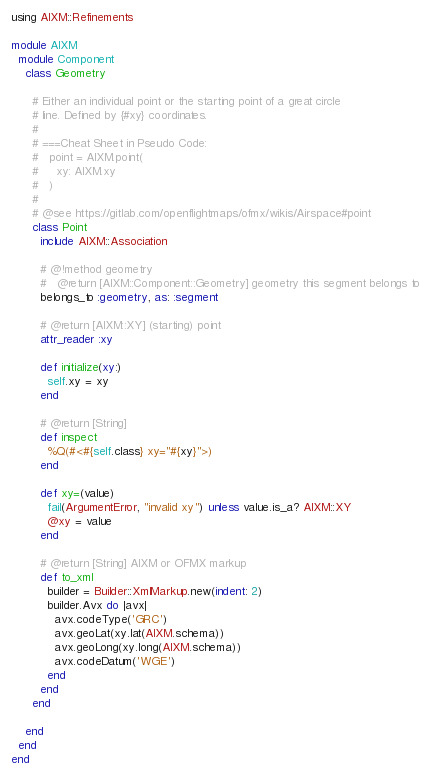Convert code to text. <code><loc_0><loc_0><loc_500><loc_500><_Ruby_>using AIXM::Refinements

module AIXM
  module Component
    class Geometry

      # Either an individual point or the starting point of a great circle
      # line. Defined by {#xy} coordinates.
      #
      # ===Cheat Sheet in Pseudo Code:
      #   point = AIXM.point(
      #     xy: AIXM.xy
      #   )
      #
      # @see https://gitlab.com/openflightmaps/ofmx/wikis/Airspace#point
      class Point
        include AIXM::Association

        # @!method geometry
        #   @return [AIXM::Component::Geometry] geometry this segment belongs to
        belongs_to :geometry, as: :segment

        # @return [AIXM::XY] (starting) point
        attr_reader :xy

        def initialize(xy:)
          self.xy = xy
        end

        # @return [String]
        def inspect
          %Q(#<#{self.class} xy="#{xy}">)
        end

        def xy=(value)
          fail(ArgumentError, "invalid xy") unless value.is_a? AIXM::XY
          @xy = value
        end

        # @return [String] AIXM or OFMX markup
        def to_xml
          builder = Builder::XmlMarkup.new(indent: 2)
          builder.Avx do |avx|
            avx.codeType('GRC')
            avx.geoLat(xy.lat(AIXM.schema))
            avx.geoLong(xy.long(AIXM.schema))
            avx.codeDatum('WGE')
          end
        end
      end

    end
  end
end
</code> 